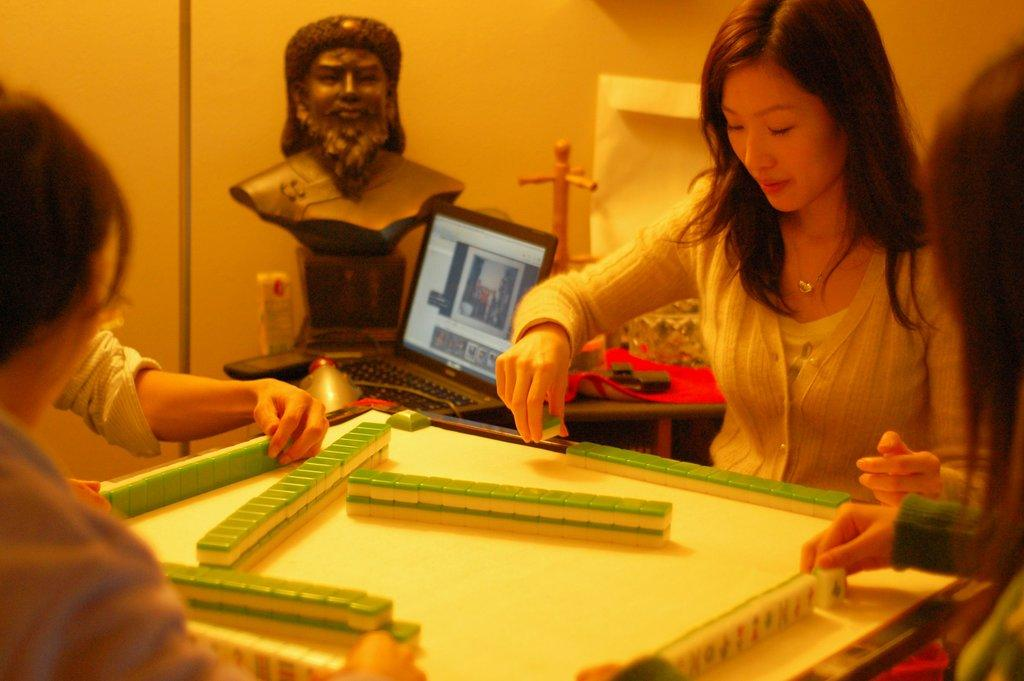What is happening in the image? There are four women playing in the image. What can be seen in the background of the image? There is a person's object, a laptop, a red cloth on a table, and a plain yellow color wall in the background. Where is the scarecrow located in the image? There is no scarecrow present in the image. What type of iron is being used by the women in the image? There is no iron visible in the image, and the women are playing, not using any iron-related objects. 